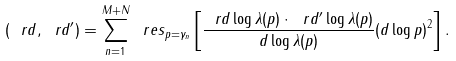<formula> <loc_0><loc_0><loc_500><loc_500>( \ r d , \ r d ^ { \prime } ) = \sum _ { n = 1 } ^ { M + N } \ r e s _ { p = \gamma _ { n } } \left [ \frac { \ r d \log \lambda ( p ) \cdot \ r d ^ { \prime } \log \lambda ( p ) } { d \log \lambda ( p ) } ( d \log p ) ^ { 2 } \right ] .</formula> 